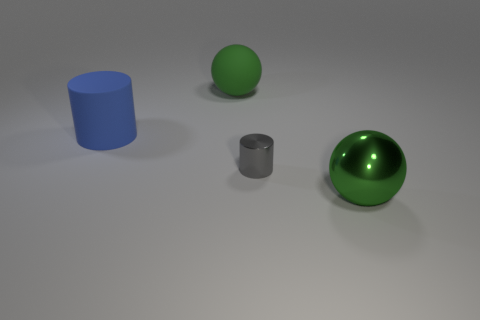The large green thing to the left of the cylinder right of the green object that is behind the big matte cylinder is what shape?
Offer a terse response. Sphere. The large green thing that is on the right side of the big green thing to the left of the tiny gray metal cylinder is what shape?
Make the answer very short. Sphere. Are there any large red cubes that have the same material as the blue object?
Give a very brief answer. No. The shiny sphere that is the same color as the big matte sphere is what size?
Keep it short and to the point. Large. What number of yellow objects are large matte spheres or rubber cylinders?
Offer a very short reply. 0. Are there any large rubber cylinders of the same color as the small metallic cylinder?
Ensure brevity in your answer.  No. What is the size of the sphere that is made of the same material as the small thing?
Ensure brevity in your answer.  Large. How many blocks are either tiny brown rubber objects or large blue objects?
Offer a terse response. 0. Is the number of green metal things greater than the number of large gray things?
Your answer should be compact. Yes. How many gray objects have the same size as the metallic cylinder?
Provide a succinct answer. 0. 